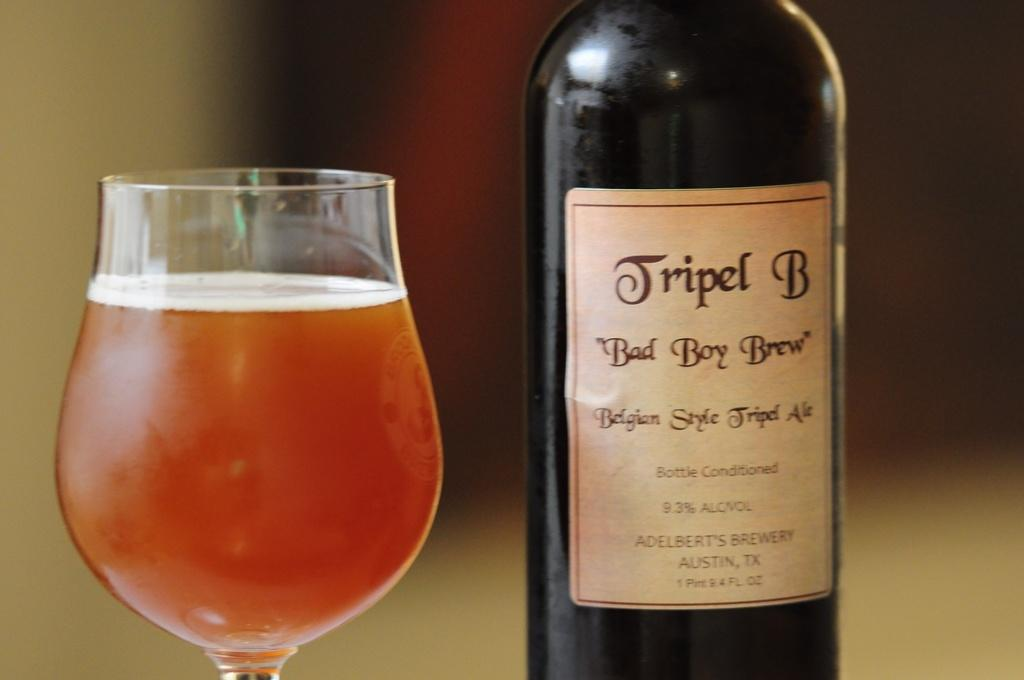<image>
Offer a succinct explanation of the picture presented. A bottle is labeled as bad boy brew and is next to a filled glass. 